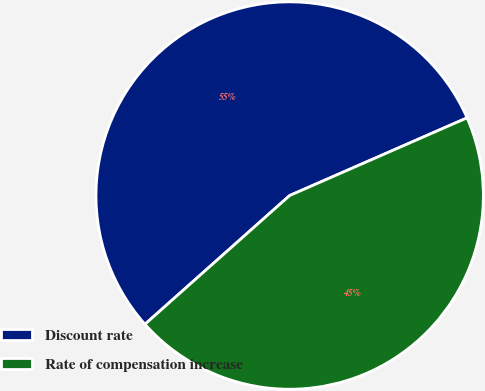<chart> <loc_0><loc_0><loc_500><loc_500><pie_chart><fcel>Discount rate<fcel>Rate of compensation increase<nl><fcel>55.0%<fcel>45.0%<nl></chart> 